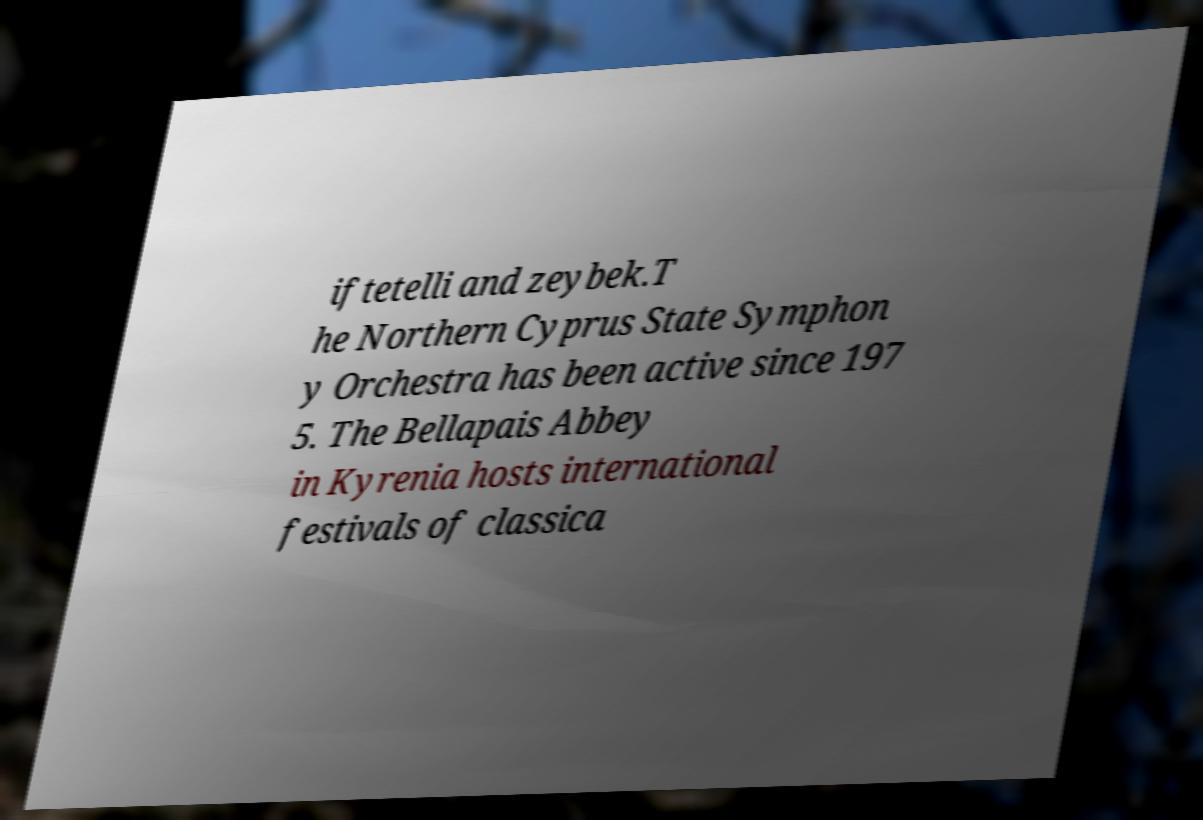Can you read and provide the text displayed in the image?This photo seems to have some interesting text. Can you extract and type it out for me? iftetelli and zeybek.T he Northern Cyprus State Symphon y Orchestra has been active since 197 5. The Bellapais Abbey in Kyrenia hosts international festivals of classica 